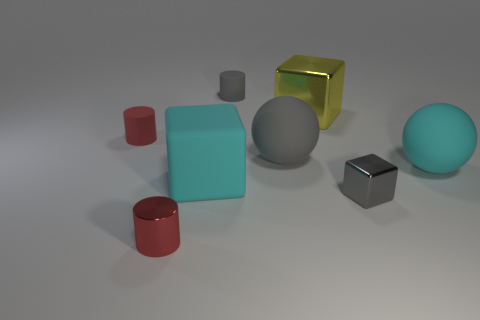There is a thing that is the same color as the large matte cube; what is it made of?
Keep it short and to the point. Rubber. There is a big rubber object that is behind the cyan sphere; is it the same color as the metal block in front of the red rubber object?
Offer a very short reply. Yes. How many big blocks are there?
Your response must be concise. 2. There is a gray cube; are there any big cyan balls in front of it?
Offer a very short reply. No. Are the gray cylinder behind the shiny cylinder and the ball left of the tiny block made of the same material?
Offer a terse response. Yes. Is the number of large rubber cubes that are behind the large yellow thing less than the number of small red metallic cylinders?
Your response must be concise. Yes. What is the color of the shiny thing that is left of the small gray cylinder?
Make the answer very short. Red. There is a large sphere that is to the left of the shiny block on the right side of the yellow object; what is its material?
Offer a terse response. Rubber. Is there a yellow object that has the same size as the gray metal thing?
Your answer should be very brief. No. How many objects are either big matte objects on the left side of the large gray rubber object or gray matte things behind the large yellow metal object?
Offer a terse response. 2. 